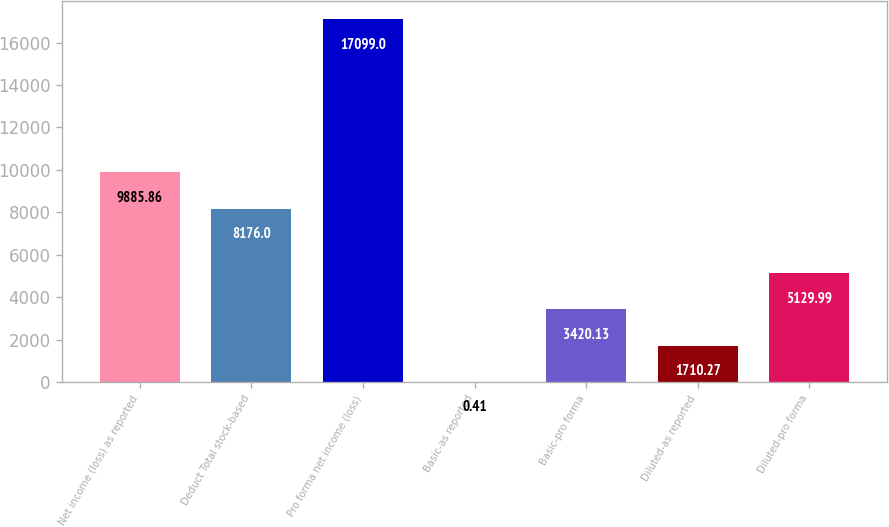Convert chart. <chart><loc_0><loc_0><loc_500><loc_500><bar_chart><fcel>Net income (loss) as reported<fcel>Deduct Total stock-based<fcel>Pro forma net income (loss)<fcel>Basic-as reported<fcel>Basic-pro forma<fcel>Diluted-as reported<fcel>Diluted-pro forma<nl><fcel>9885.86<fcel>8176<fcel>17099<fcel>0.41<fcel>3420.13<fcel>1710.27<fcel>5129.99<nl></chart> 